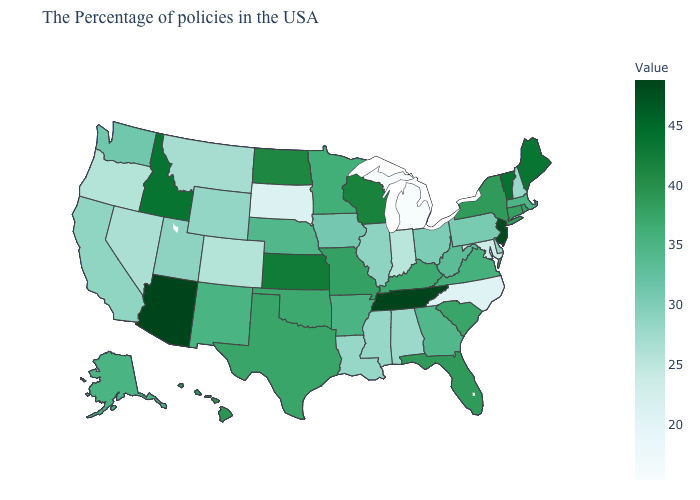Does the map have missing data?
Write a very short answer. No. Which states have the lowest value in the USA?
Short answer required. Michigan. Which states hav the highest value in the West?
Concise answer only. Arizona. Which states have the highest value in the USA?
Keep it brief. Tennessee, Arizona. Does Pennsylvania have the highest value in the USA?
Be succinct. No. 